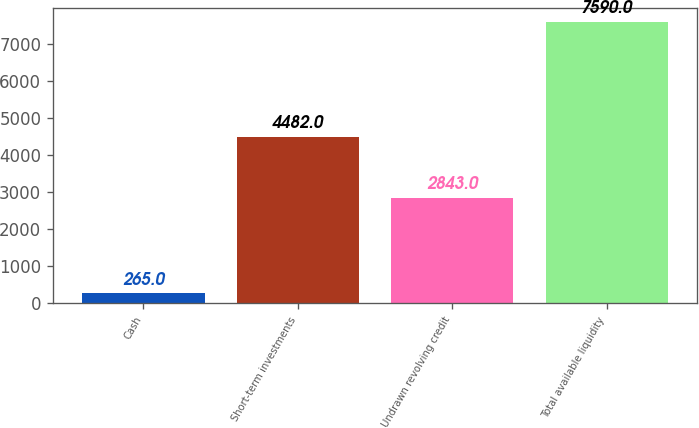<chart> <loc_0><loc_0><loc_500><loc_500><bar_chart><fcel>Cash<fcel>Short-term investments<fcel>Undrawn revolving credit<fcel>Total available liquidity<nl><fcel>265<fcel>4482<fcel>2843<fcel>7590<nl></chart> 